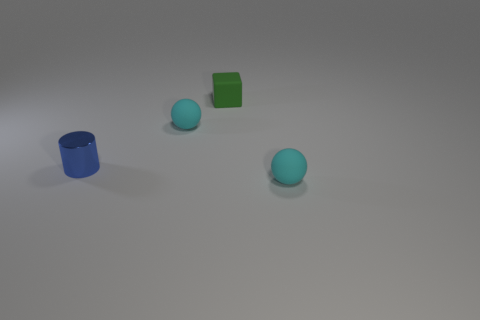What color is the thing that is behind the blue cylinder and in front of the green rubber object?
Your answer should be very brief. Cyan. There is a blue cylinder that is to the left of the block; does it have the same size as the tiny green matte cube?
Your answer should be very brief. Yes. Are there any other things that have the same shape as the shiny thing?
Your answer should be very brief. No. Is the material of the cylinder the same as the cyan thing that is right of the block?
Provide a succinct answer. No. How many gray objects are either small rubber objects or balls?
Provide a succinct answer. 0. Are there any matte blocks?
Ensure brevity in your answer.  Yes. Is there a tiny metallic cylinder that is behind the cyan ball that is behind the sphere that is in front of the cylinder?
Ensure brevity in your answer.  No. Is there anything else that has the same size as the green cube?
Your response must be concise. Yes. Is the shape of the blue thing the same as the tiny object in front of the blue cylinder?
Keep it short and to the point. No. There is a tiny object that is behind the cyan matte ball that is on the left side of the tiny cyan matte sphere that is to the right of the green rubber cube; what color is it?
Your answer should be compact. Green. 